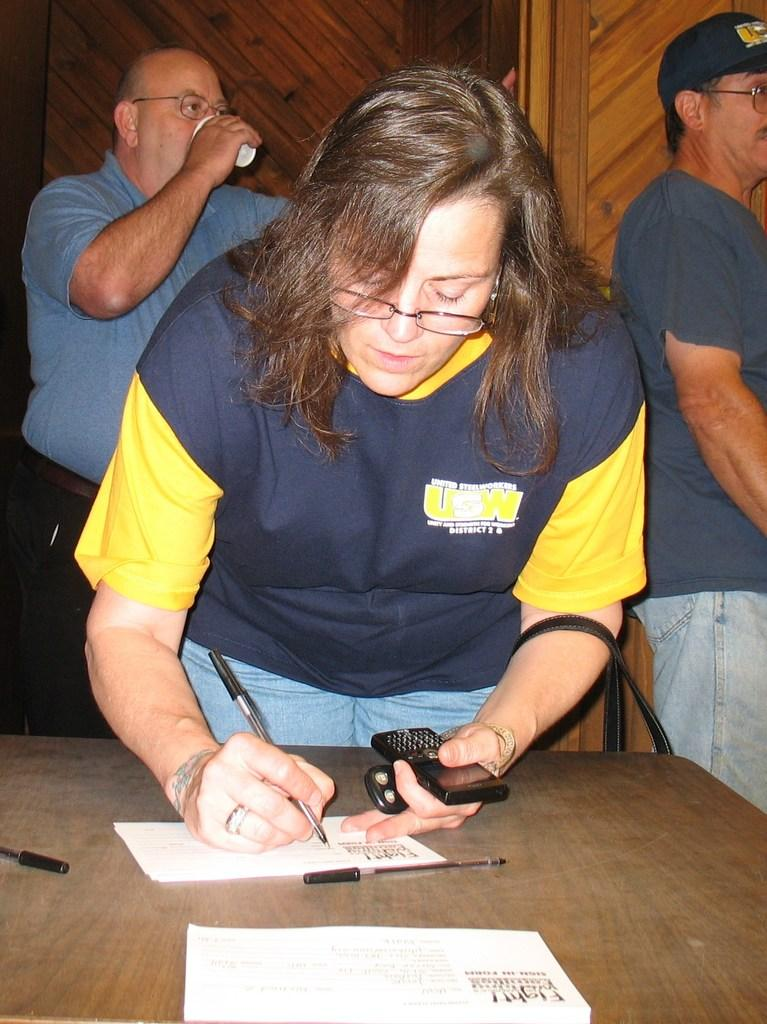Who is the main subject in the image? There is a woman in the image. What is the woman doing in the image? The woman is writing on a paper. What objects are present on the table in the image? There are pens on a table in the image. Can you describe the other people in the image? There are people in the image, but their specific actions or roles are not mentioned in the provided facts. What type of vase is present on the table in the image? There is no vase present on the table in the image; only pens are mentioned. What kind of test is the woman taking in the image? The provided facts do not mention any test or assessment; the woman is simply writing on a paper. 